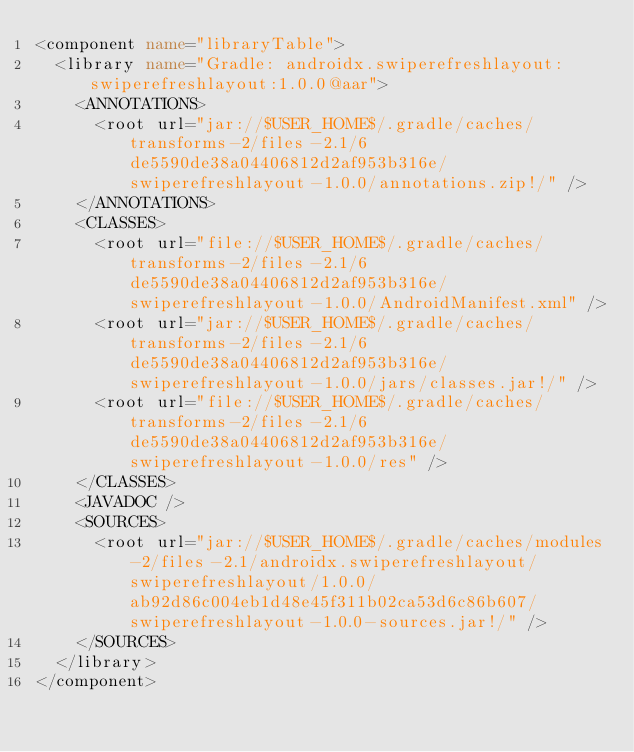Convert code to text. <code><loc_0><loc_0><loc_500><loc_500><_XML_><component name="libraryTable">
  <library name="Gradle: androidx.swiperefreshlayout:swiperefreshlayout:1.0.0@aar">
    <ANNOTATIONS>
      <root url="jar://$USER_HOME$/.gradle/caches/transforms-2/files-2.1/6de5590de38a04406812d2af953b316e/swiperefreshlayout-1.0.0/annotations.zip!/" />
    </ANNOTATIONS>
    <CLASSES>
      <root url="file://$USER_HOME$/.gradle/caches/transforms-2/files-2.1/6de5590de38a04406812d2af953b316e/swiperefreshlayout-1.0.0/AndroidManifest.xml" />
      <root url="jar://$USER_HOME$/.gradle/caches/transforms-2/files-2.1/6de5590de38a04406812d2af953b316e/swiperefreshlayout-1.0.0/jars/classes.jar!/" />
      <root url="file://$USER_HOME$/.gradle/caches/transforms-2/files-2.1/6de5590de38a04406812d2af953b316e/swiperefreshlayout-1.0.0/res" />
    </CLASSES>
    <JAVADOC />
    <SOURCES>
      <root url="jar://$USER_HOME$/.gradle/caches/modules-2/files-2.1/androidx.swiperefreshlayout/swiperefreshlayout/1.0.0/ab92d86c004eb1d48e45f311b02ca53d6c86b607/swiperefreshlayout-1.0.0-sources.jar!/" />
    </SOURCES>
  </library>
</component></code> 